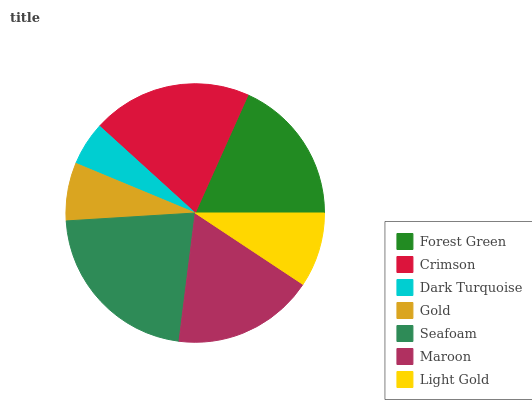Is Dark Turquoise the minimum?
Answer yes or no. Yes. Is Seafoam the maximum?
Answer yes or no. Yes. Is Crimson the minimum?
Answer yes or no. No. Is Crimson the maximum?
Answer yes or no. No. Is Crimson greater than Forest Green?
Answer yes or no. Yes. Is Forest Green less than Crimson?
Answer yes or no. Yes. Is Forest Green greater than Crimson?
Answer yes or no. No. Is Crimson less than Forest Green?
Answer yes or no. No. Is Maroon the high median?
Answer yes or no. Yes. Is Maroon the low median?
Answer yes or no. Yes. Is Dark Turquoise the high median?
Answer yes or no. No. Is Light Gold the low median?
Answer yes or no. No. 